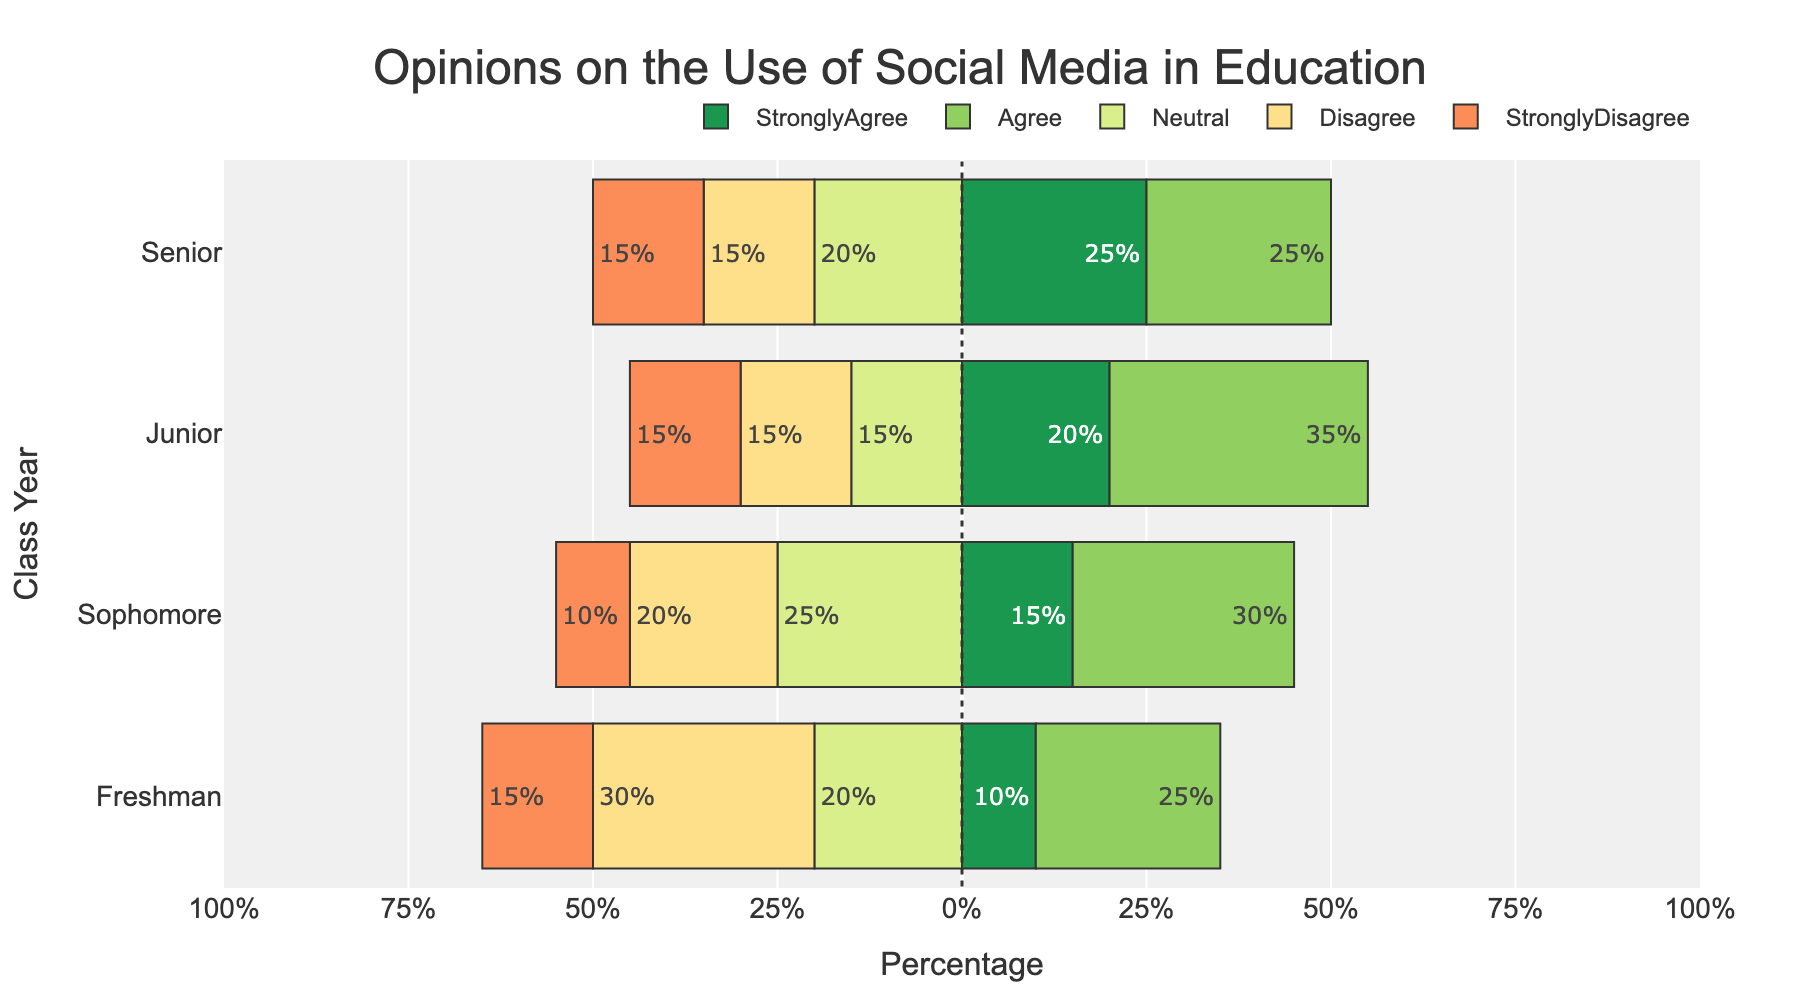How many students overall agree (either Strongly Agree or Agree) with the use of social media in education among all class years? First, sum up the values for "Strongly Agree" and "Agree" for each class year: (10 + 25) for Freshman, (15 + 30) for Sophomore, (20 + 35) for Junior, and (25 + 25) for Senior. Then sum these totals to get the overall number of students who agree. The calculation is (35 + 45 + 55 + 50) = 185.
Answer: 185 Which class year has the highest percentage of students who Strongly Disagree? Look at the lengths of the bars representing "Strongly Disagree" and compare them across the class years. The Freshman, Junior, and Senior classes each have 15%, while Sophomores have 10%. Therefore, Freshman, Junior, and Senior classes are tied with the highest percentage at 15%.
Answer: Freshman, Junior, and Senior What is the percentage difference in Neutral opinions between Sophomores and Seniors? Find the values for Neutral opinions for both class years and subtract them. For Sophomores, the value is 25%, and for Seniors, it is 20%. The difference is 25% - 20%, which equals 5%.
Answer: 5% Which class year shows the most balanced opinions across all categories? Check which class year has the most evenly distributed lengths of the bars across all categories. The balance can be observed by looking at how even the distribution of percentages is. Junior year seems the most balanced as the values are 20%, 35%, 15%, 15%, and 15%, showing no extreme large or small values.
Answer: Junior What is the sum of Neutral opinions from Freshmen and Juniors? Sum the values for Neutral opinions for Freshmen and Juniors. For Freshmen, the value is 20%, and for Juniors, it is 15%. The sum is 20% + 15% = 35%.
Answer: 35% Which class year has the highest total for Strongly Agree and Neutral combined? Add the percentages for Strongly Agree and Neutral for each class year. Freshman: 10% + 20% = 30%. Sophomore: 15% + 25% = 40%. Junior: 20% + 15% = 35%. Senior: 25% + 20% = 45%. The Senior class has the highest combined percentage at 45%.
Answer: Senior Which opinion category is the most popular among Juniors? Find the category with the longest bar in the Junior class. The "Agree" category has the longest bar with 35%.
Answer: Agree 